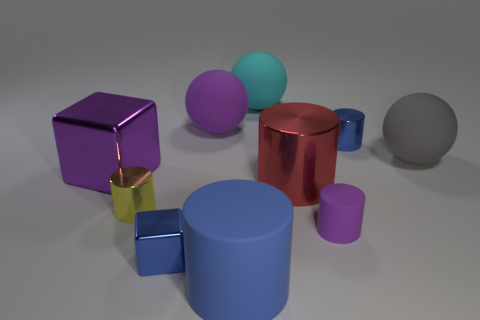How many other objects are there of the same color as the small matte cylinder?
Ensure brevity in your answer.  2. What is the material of the big object that is the same color as the big block?
Offer a terse response. Rubber. There is a small rubber object; does it have the same color as the large thing to the left of the tiny blue block?
Give a very brief answer. Yes. What shape is the purple rubber thing in front of the large purple metallic object?
Offer a very short reply. Cylinder. What number of other things are there of the same material as the small purple cylinder
Provide a succinct answer. 4. What material is the purple cylinder?
Offer a terse response. Rubber. What number of tiny objects are either blue rubber things or cyan rubber spheres?
Your response must be concise. 0. What number of large objects are behind the big gray thing?
Offer a very short reply. 2. Are there any small cubes of the same color as the big rubber cylinder?
Your answer should be very brief. Yes. The purple matte object that is the same size as the yellow metal cylinder is what shape?
Offer a very short reply. Cylinder. 